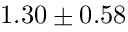Convert formula to latex. <formula><loc_0><loc_0><loc_500><loc_500>1 . 3 0 \pm 0 . 5 8</formula> 